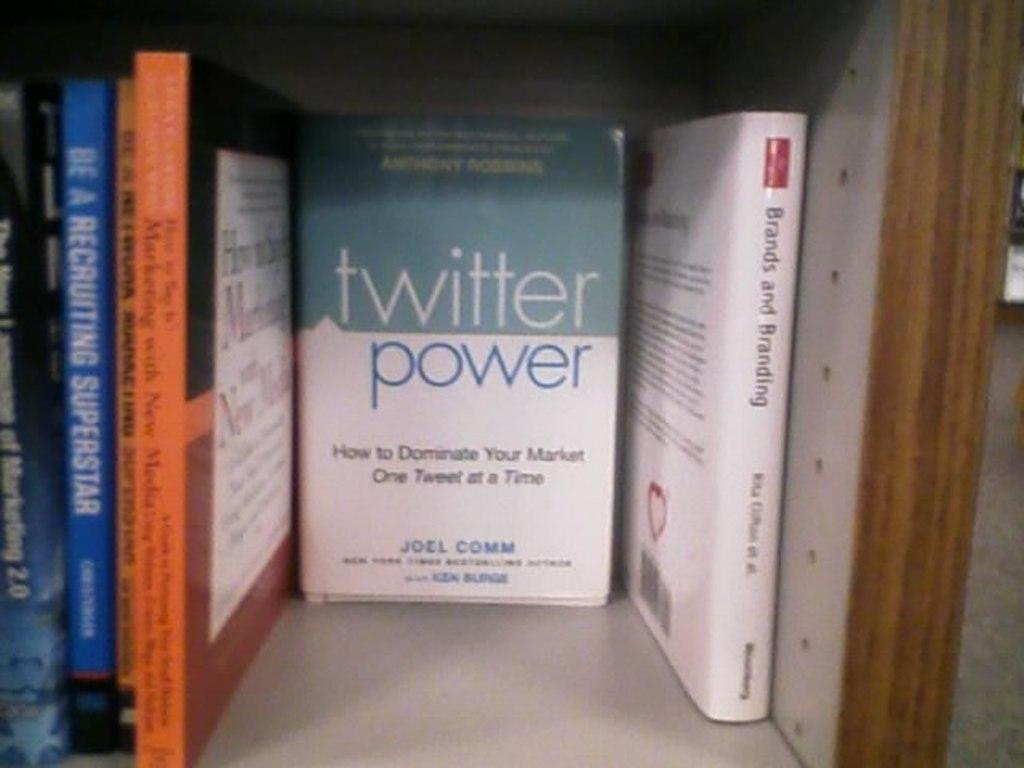<image>
Describe the image concisely. A book shelf with books such as twitter power by Joel Comm. 